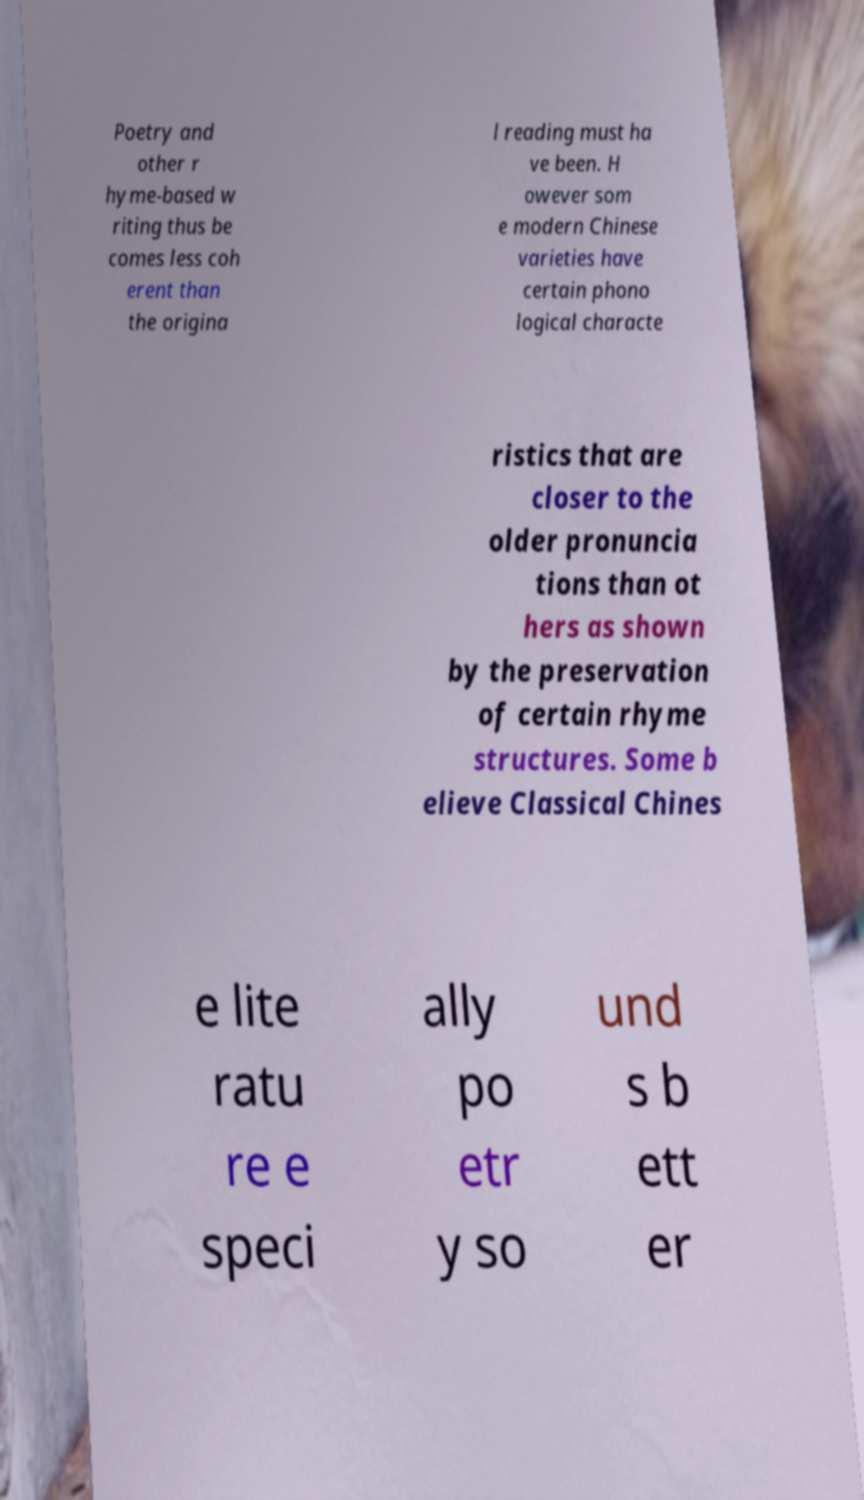I need the written content from this picture converted into text. Can you do that? Poetry and other r hyme-based w riting thus be comes less coh erent than the origina l reading must ha ve been. H owever som e modern Chinese varieties have certain phono logical characte ristics that are closer to the older pronuncia tions than ot hers as shown by the preservation of certain rhyme structures. Some b elieve Classical Chines e lite ratu re e speci ally po etr y so und s b ett er 